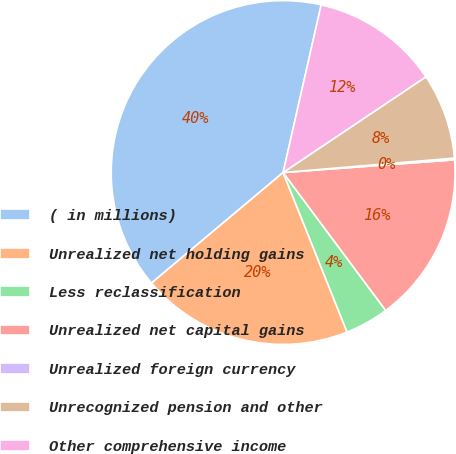Convert chart. <chart><loc_0><loc_0><loc_500><loc_500><pie_chart><fcel>( in millions)<fcel>Unrealized net holding gains<fcel>Less reclassification<fcel>Unrealized net capital gains<fcel>Unrealized foreign currency<fcel>Unrecognized pension and other<fcel>Other comprehensive income<nl><fcel>39.67%<fcel>19.95%<fcel>4.11%<fcel>16.0%<fcel>0.16%<fcel>8.06%<fcel>12.05%<nl></chart> 